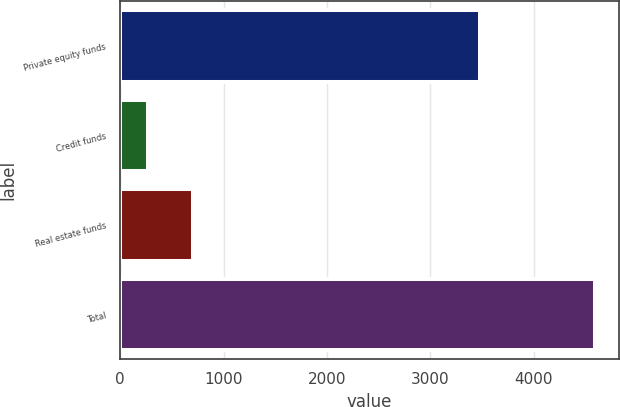Convert chart. <chart><loc_0><loc_0><loc_500><loc_500><bar_chart><fcel>Private equity funds<fcel>Credit funds<fcel>Real estate funds<fcel>Total<nl><fcel>3478<fcel>266<fcel>699<fcel>4596<nl></chart> 